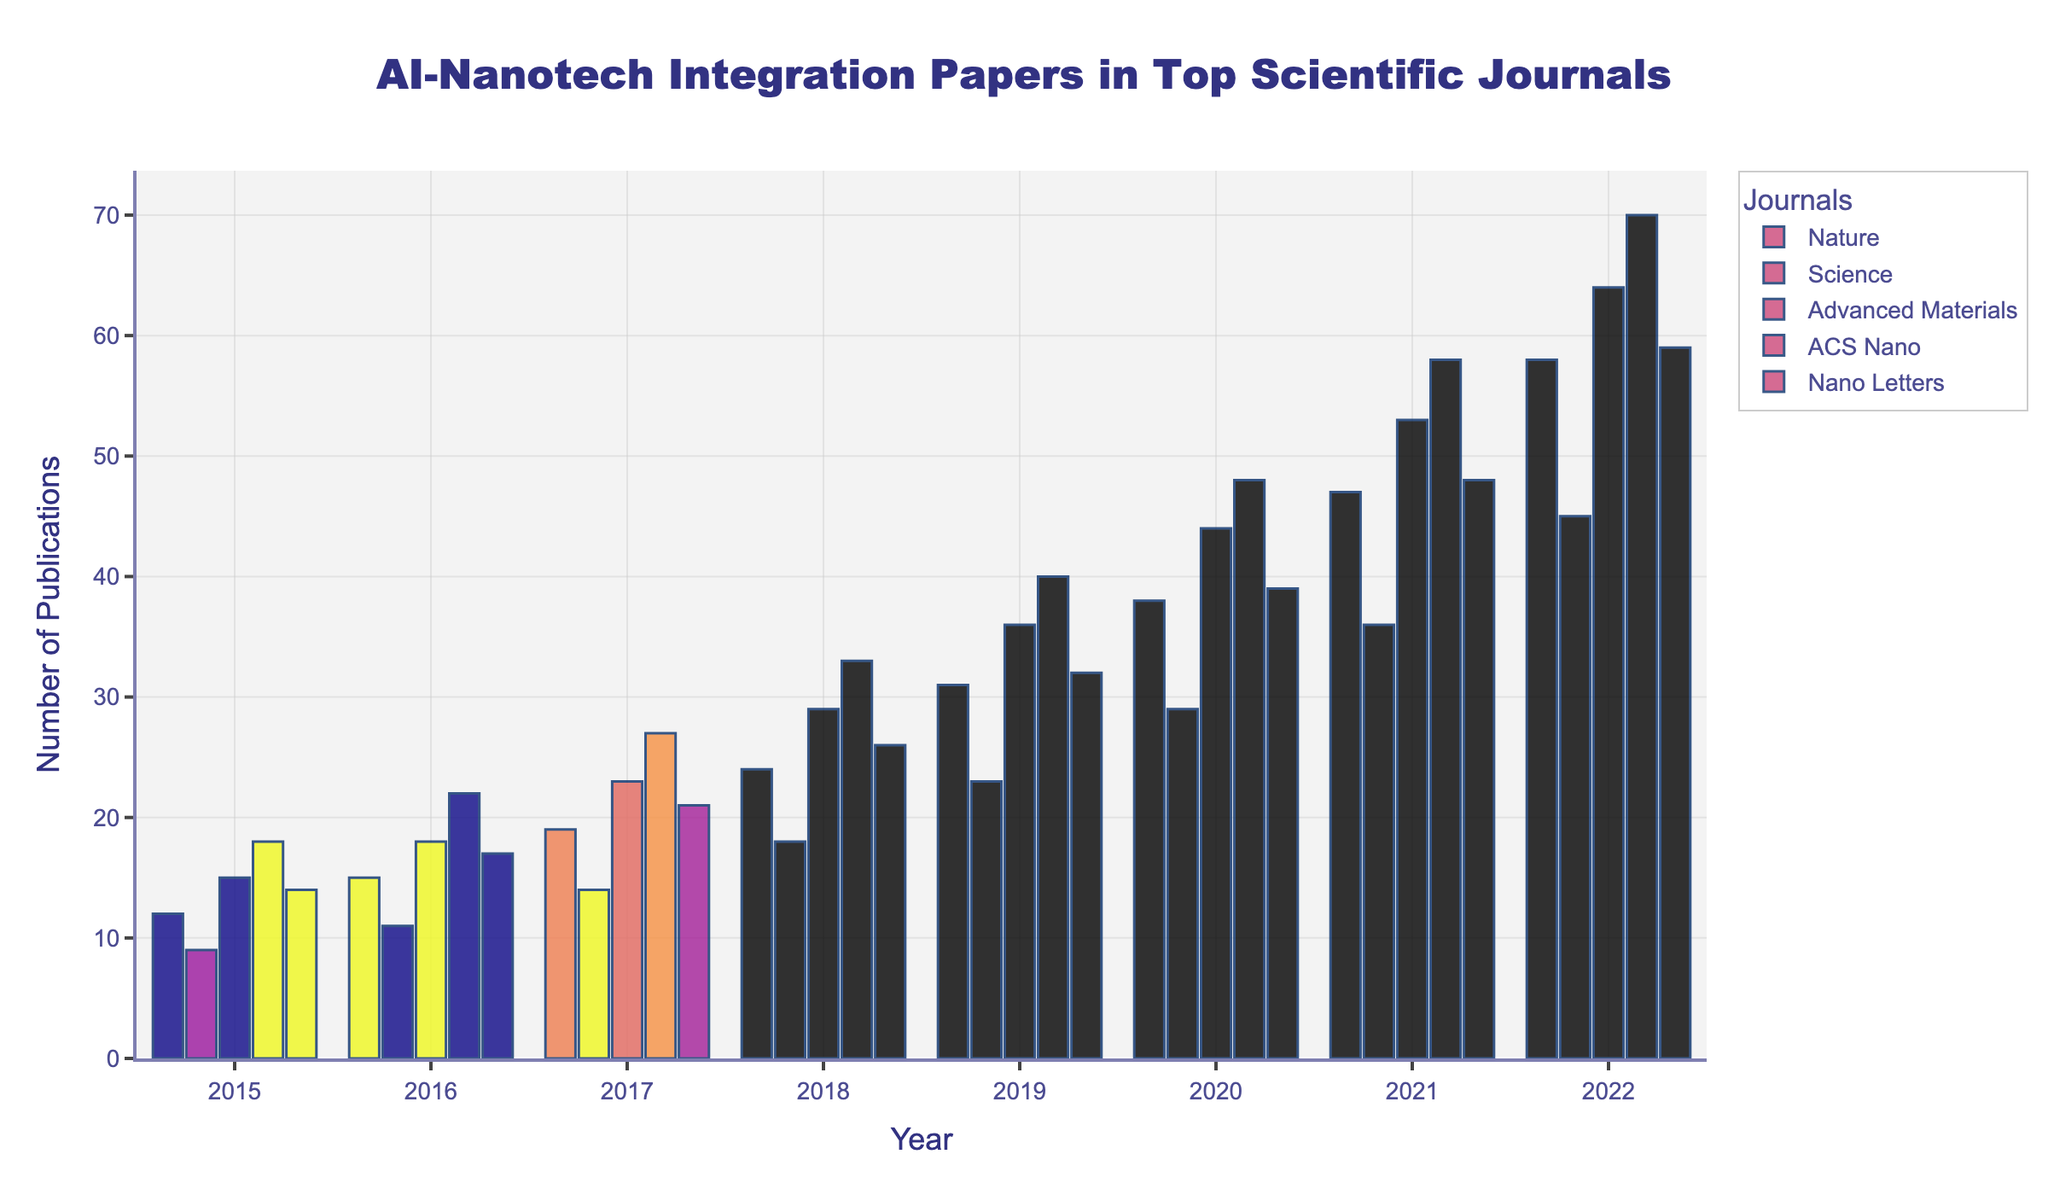What's the total number of AI-nanotech integration papers published in Nature and Science combined in 2018? First, identify the number of papers published in Nature in 2018 (24). Then do the same for Science (18). Add these numbers together: 24 + 18 = 42.
Answer: 42 Which journal had the highest number of publications in 2022? Look at the bars for the year 2022 and identify the one with the greatest height, which corresponds to the highest number of publications. The tallest bar is for "ACS Nano," having 70 papers.
Answer: ACS Nano What is the overall trend in the number of AI-nanotech papers published in Nano Letters from 2015 to 2022? Observe the height of the bars for Nano Letters from 2015 to 2022. The heights of the bars are increasing each year, indicating a rising trend in the number of publications.
Answer: Increasing Which year saw the largest increase in publications for Advanced Materials compared to the previous year? Calculate the differences between consecutive years: 2016-2015: 18-15=3, 2017-2016: 23-18=5, 2018-2017: 29-23=6, 2019-2018: 36-29=7, 2020-2019: 44-36=8, 2021-2020: 53-44=9, 2022-2021: 64-53=11. The largest increase is from 2021 to 2022 (11 papers).
Answer: 2022 How many AI-nanotech papers were published in ACS Nano in 2017 compared to Nano Letters in the same year? Identify the number of papers published in ACS Nano in 2017 (27) and the number in Nano Letters in the same year (21). The difference is 27 - 21 = 6.
Answer: 6 Which journal has shown the most consistent year-on-year growth in AI-nanotech publications? Examine the bars for each journal year-by-year, checking for relatively steady increments. "ACS Nano" shows a consistent increase each year, without any drop or plateau.
Answer: ACS Nano In which year did the number of AI-nanotech papers in Nature surpass 30? Look at the bar representing Nature for each year and find the year when the height first exceeds 30. The year is 2019.
Answer: 2019 